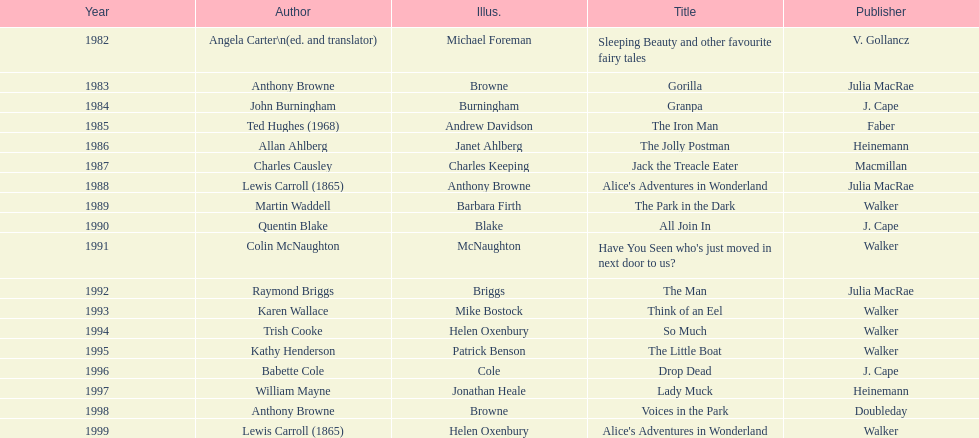What are the number of kurt maschler awards helen oxenbury has won? 2. 